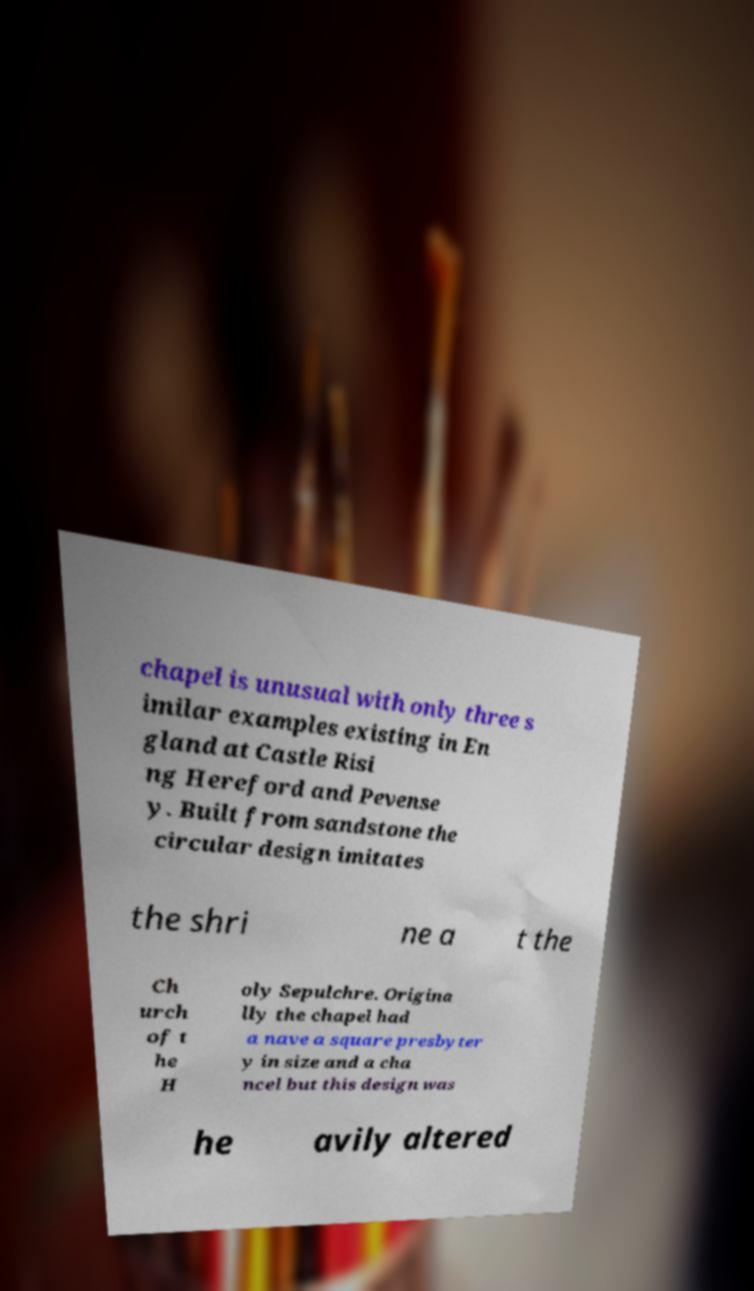Can you accurately transcribe the text from the provided image for me? chapel is unusual with only three s imilar examples existing in En gland at Castle Risi ng Hereford and Pevense y. Built from sandstone the circular design imitates the shri ne a t the Ch urch of t he H oly Sepulchre. Origina lly the chapel had a nave a square presbyter y in size and a cha ncel but this design was he avily altered 